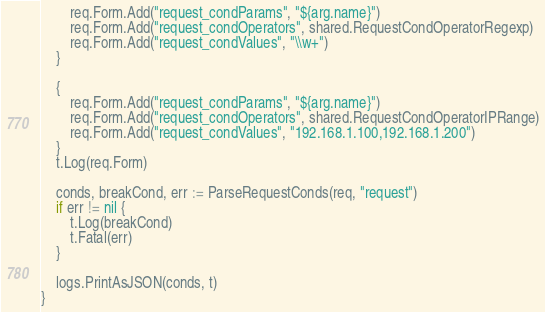<code> <loc_0><loc_0><loc_500><loc_500><_Go_>		req.Form.Add("request_condParams", "${arg.name}")
		req.Form.Add("request_condOperators", shared.RequestCondOperatorRegexp)
		req.Form.Add("request_condValues", "\\w+")
	}

	{
		req.Form.Add("request_condParams", "${arg.name}")
		req.Form.Add("request_condOperators", shared.RequestCondOperatorIPRange)
		req.Form.Add("request_condValues", "192.168.1.100,192.168.1.200")
	}
	t.Log(req.Form)

	conds, breakCond, err := ParseRequestConds(req, "request")
	if err != nil {
		t.Log(breakCond)
		t.Fatal(err)
	}

	logs.PrintAsJSON(conds, t)
}
</code> 